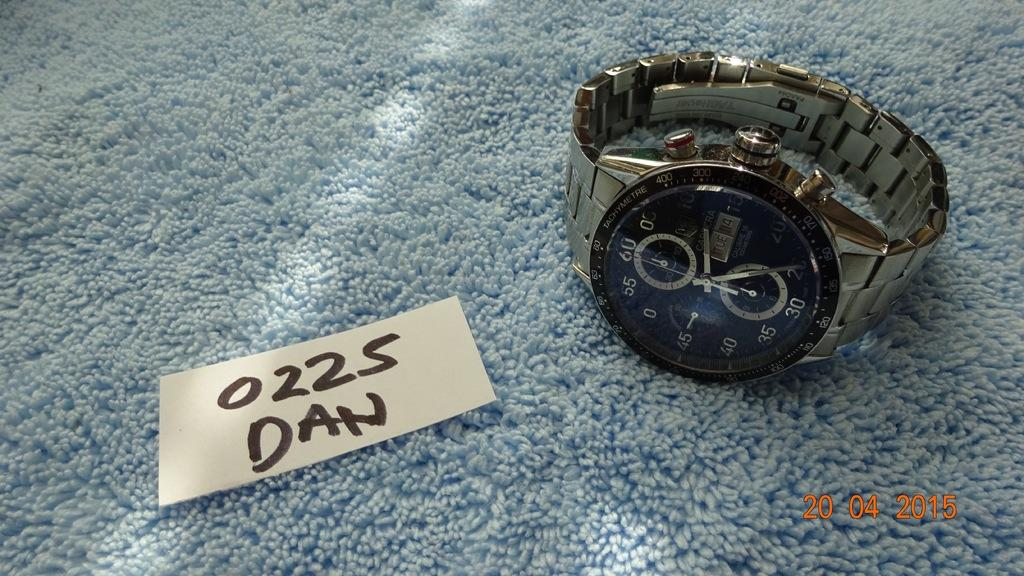<image>
Write a terse but informative summary of the picture. A watch is on a blue carpet next to a note that says 0225 Dan. 